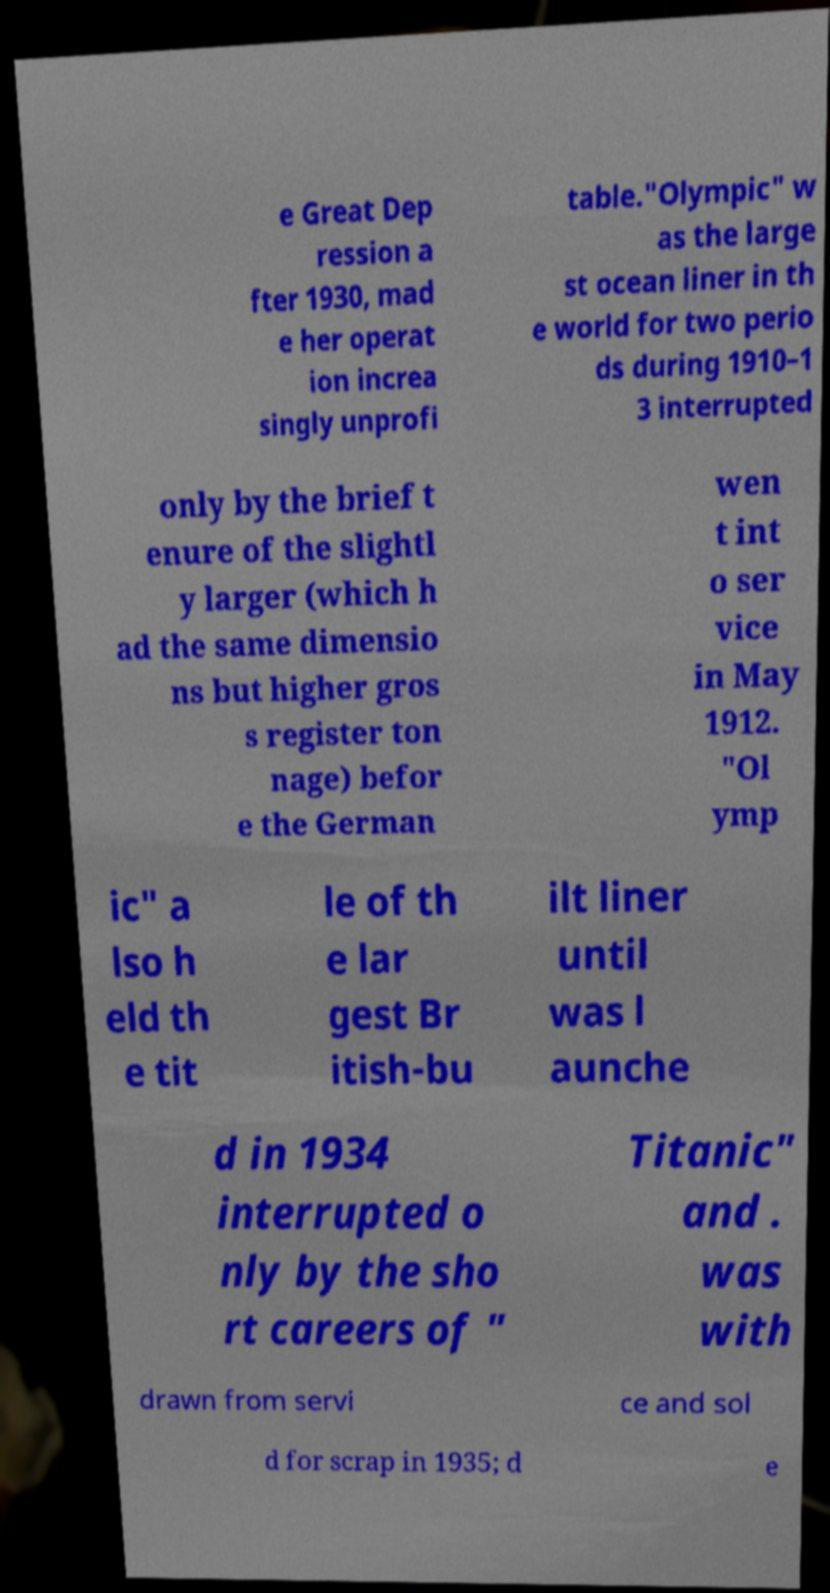Could you extract and type out the text from this image? e Great Dep ression a fter 1930, mad e her operat ion increa singly unprofi table."Olympic" w as the large st ocean liner in th e world for two perio ds during 1910–1 3 interrupted only by the brief t enure of the slightl y larger (which h ad the same dimensio ns but higher gros s register ton nage) befor e the German wen t int o ser vice in May 1912. "Ol ymp ic" a lso h eld th e tit le of th e lar gest Br itish-bu ilt liner until was l aunche d in 1934 interrupted o nly by the sho rt careers of " Titanic" and . was with drawn from servi ce and sol d for scrap in 1935; d e 